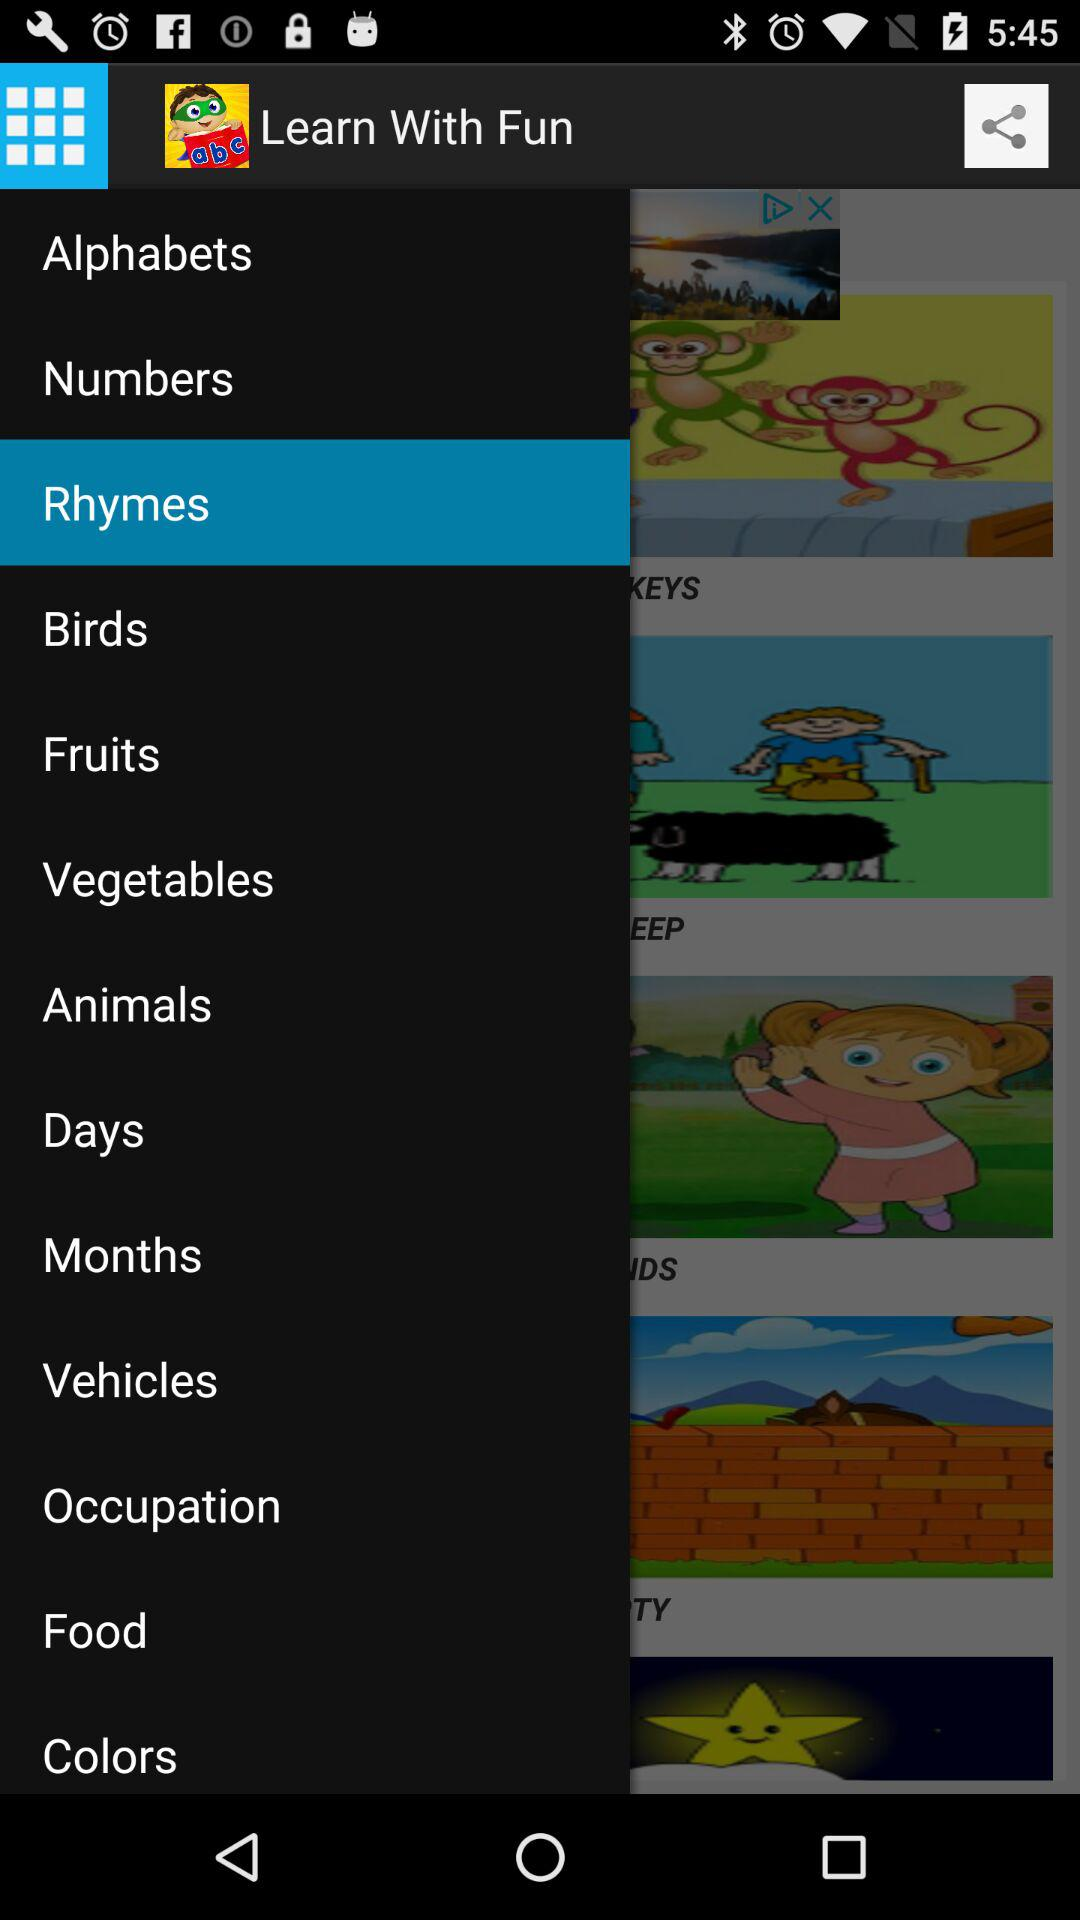Which fruits are used for learning with fun?
When the provided information is insufficient, respond with <no answer>. <no answer> 